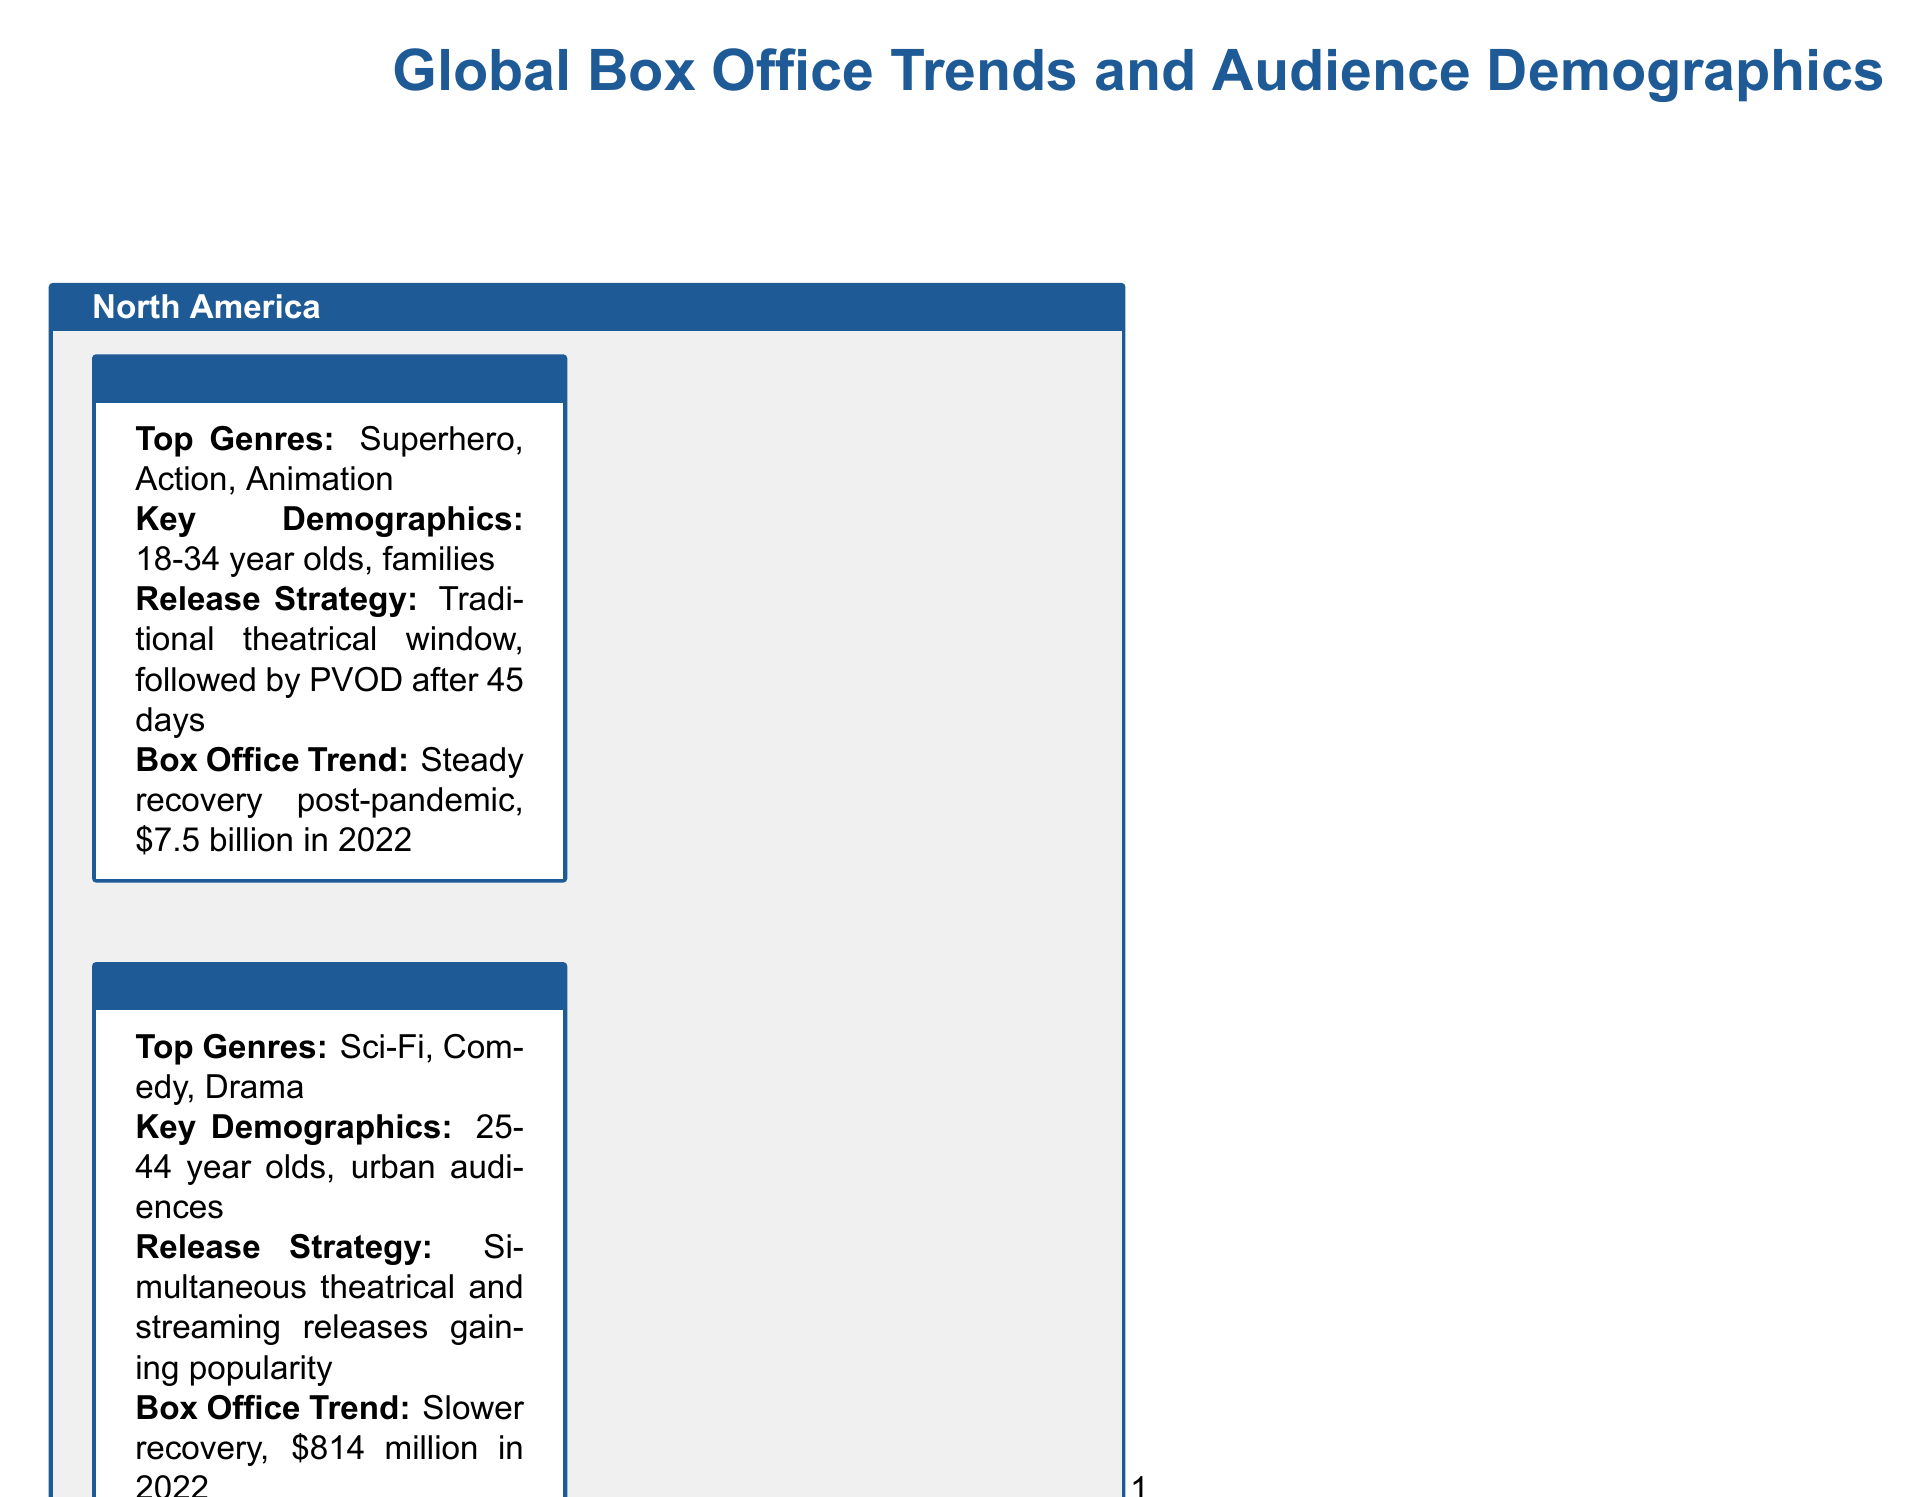what is the top genre in the United States? The document states that the top genre in the United States is Superhero.
Answer: Superhero what was the box office revenue for Canada in 2022? The document indicates that Canada's box office revenue in 2022 was $814 million.
Answer: $814 million who is the key demographic in China? According to the document, the key demographic in China is 18-35 year olds.
Answer: 18-35 year olds what release strategy is gaining popularity in Canada? The document mentions that simultaneous theatrical and streaming releases are gaining popularity in Canada.
Answer: Simultaneous theatrical and streaming releases what was the box office trend in India in 2022? The document describes India's box office trend as rapid growth.
Answer: Rapid growth which country has the largest box office market in 2022? The document states that China has the largest box office market in 2022.
Answer: China what is the key demographic for the United Kingdom? The document lists the key demographic for the United Kingdom as 18-44 year olds.
Answer: 18-44 year olds what genre is dominant in France? The document identifies Comedy as a dominant genre in France.
Answer: Comedy what was the box office revenue in Japan for 2022? The document provides that Japan's box office revenue in 2022 was $1.5 billion.
Answer: $1.5 billion 